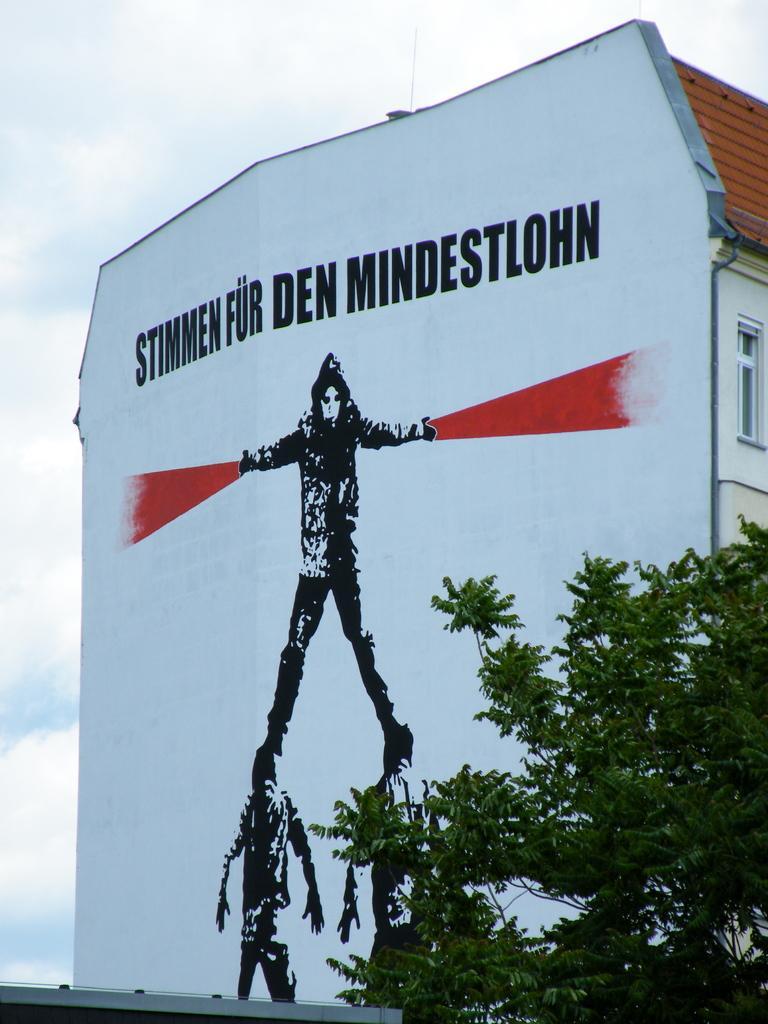Please provide a concise description of this image. Inn this image there is a building having some paintings of few persons and some text on it. Right bottom there is a tree. Top of image there is sky with some clouds. 